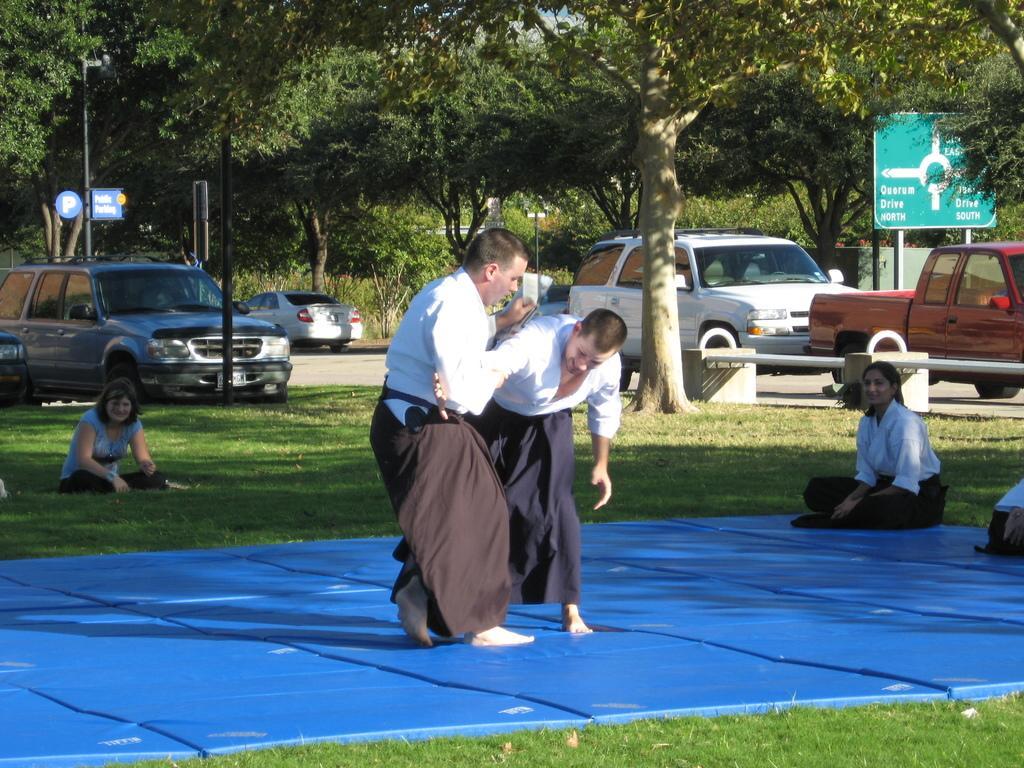Can you describe this image briefly? In this image we can see people, tatami mats, grass, road, vehicles, bench, planter, poles, boards, and trees. 